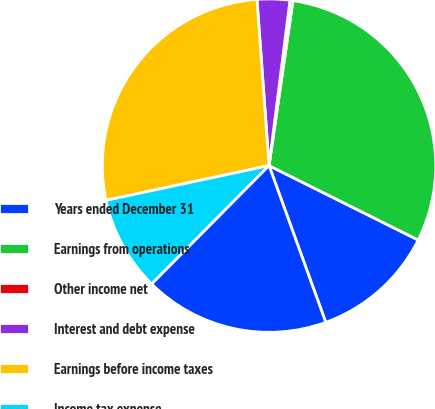<chart> <loc_0><loc_0><loc_500><loc_500><pie_chart><fcel>Years ended December 31<fcel>Earnings from operations<fcel>Other income net<fcel>Interest and debt expense<fcel>Earnings before income taxes<fcel>Income tax expense<fcel>Net earnings from continuing<nl><fcel>12.11%<fcel>30.07%<fcel>0.29%<fcel>3.16%<fcel>27.19%<fcel>9.23%<fcel>17.96%<nl></chart> 